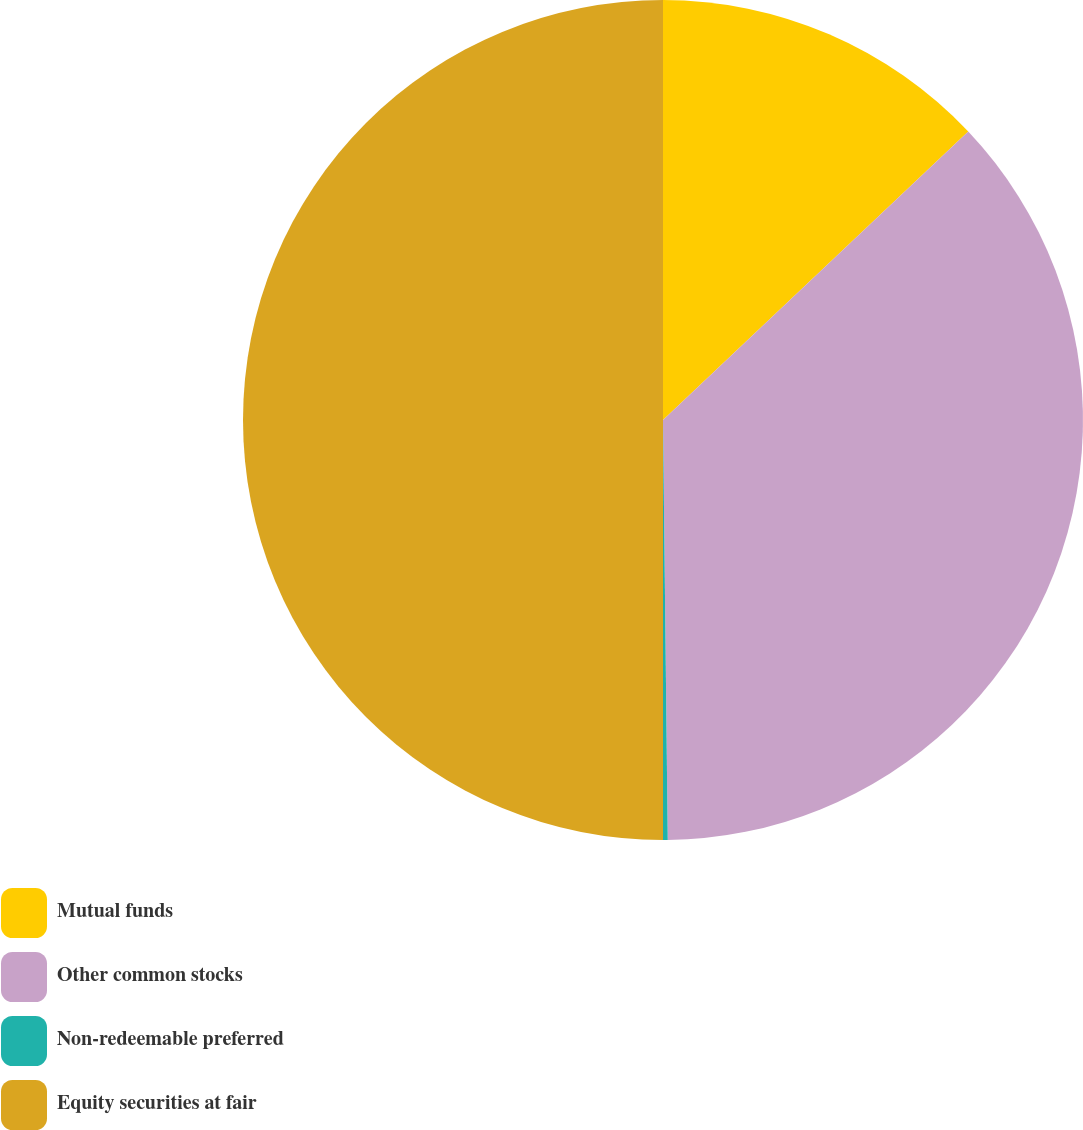Convert chart. <chart><loc_0><loc_0><loc_500><loc_500><pie_chart><fcel>Mutual funds<fcel>Other common stocks<fcel>Non-redeemable preferred<fcel>Equity securities at fair<nl><fcel>12.95%<fcel>36.87%<fcel>0.18%<fcel>50.0%<nl></chart> 